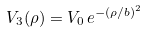<formula> <loc_0><loc_0><loc_500><loc_500>V _ { 3 } ( \rho ) = V _ { 0 } \, e ^ { - ( \rho / b ) ^ { 2 } }</formula> 